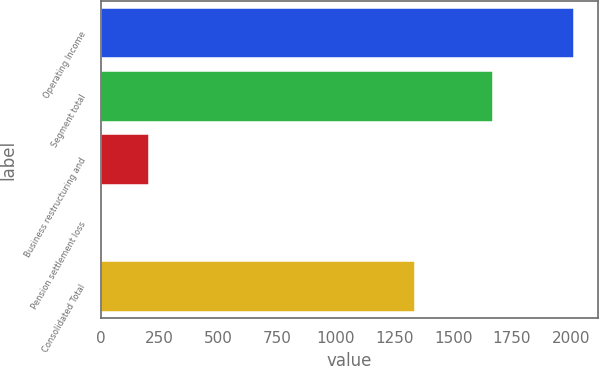<chart> <loc_0><loc_0><loc_500><loc_500><bar_chart><fcel>Operating Income<fcel>Segment total<fcel>Business restructuring and<fcel>Pension settlement loss<fcel>Consolidated Total<nl><fcel>2014<fcel>1667.4<fcel>206.35<fcel>5.5<fcel>1339.1<nl></chart> 